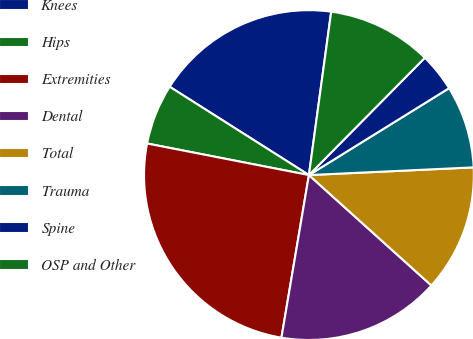<chart> <loc_0><loc_0><loc_500><loc_500><pie_chart><fcel>Knees<fcel>Hips<fcel>Extremities<fcel>Dental<fcel>Total<fcel>Trauma<fcel>Spine<fcel>OSP and Other<nl><fcel>18.16%<fcel>5.93%<fcel>25.4%<fcel>15.99%<fcel>12.42%<fcel>8.09%<fcel>3.76%<fcel>10.25%<nl></chart> 